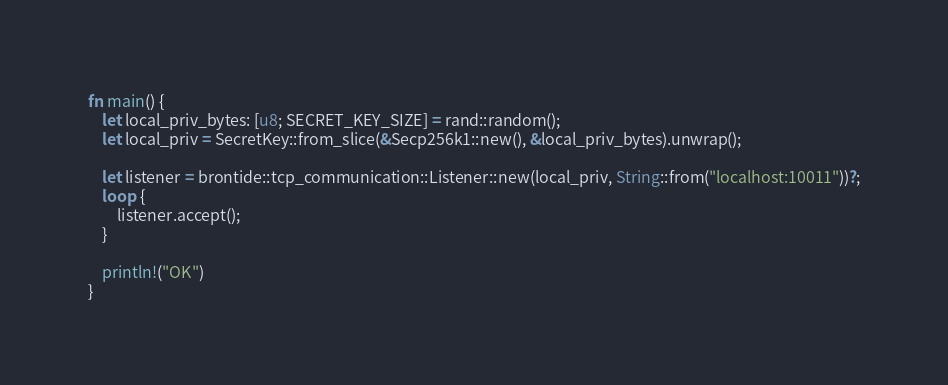<code> <loc_0><loc_0><loc_500><loc_500><_Rust_>fn main() {
    let local_priv_bytes: [u8; SECRET_KEY_SIZE] = rand::random();
    let local_priv = SecretKey::from_slice(&Secp256k1::new(), &local_priv_bytes).unwrap();

    let listener = brontide::tcp_communication::Listener::new(local_priv, String::from("localhost:10011"))?;
    loop {
        listener.accept();
    }

    println!("OK")
}</code> 